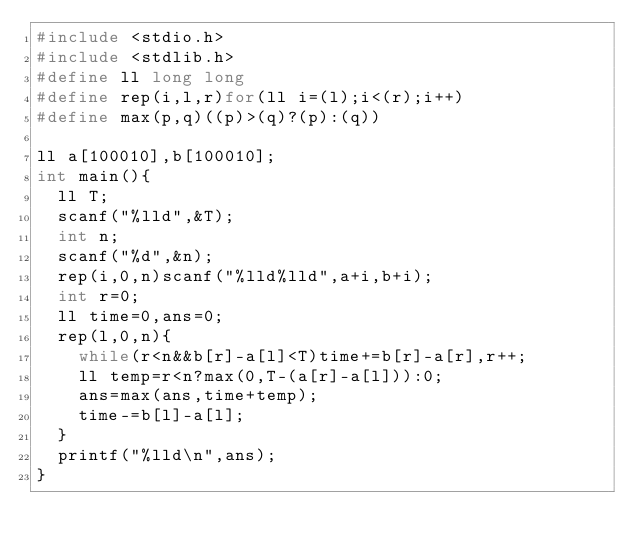<code> <loc_0><loc_0><loc_500><loc_500><_C_>#include <stdio.h>
#include <stdlib.h>
#define ll long long
#define rep(i,l,r)for(ll i=(l);i<(r);i++)
#define max(p,q)((p)>(q)?(p):(q))

ll a[100010],b[100010];
int main(){
	ll T;
	scanf("%lld",&T);
	int n;
	scanf("%d",&n);
	rep(i,0,n)scanf("%lld%lld",a+i,b+i);
	int r=0;
	ll time=0,ans=0;
	rep(l,0,n){
		while(r<n&&b[r]-a[l]<T)time+=b[r]-a[r],r++;
		ll temp=r<n?max(0,T-(a[r]-a[l])):0;
		ans=max(ans,time+temp);
		time-=b[l]-a[l];
	}
	printf("%lld\n",ans);
}
</code> 